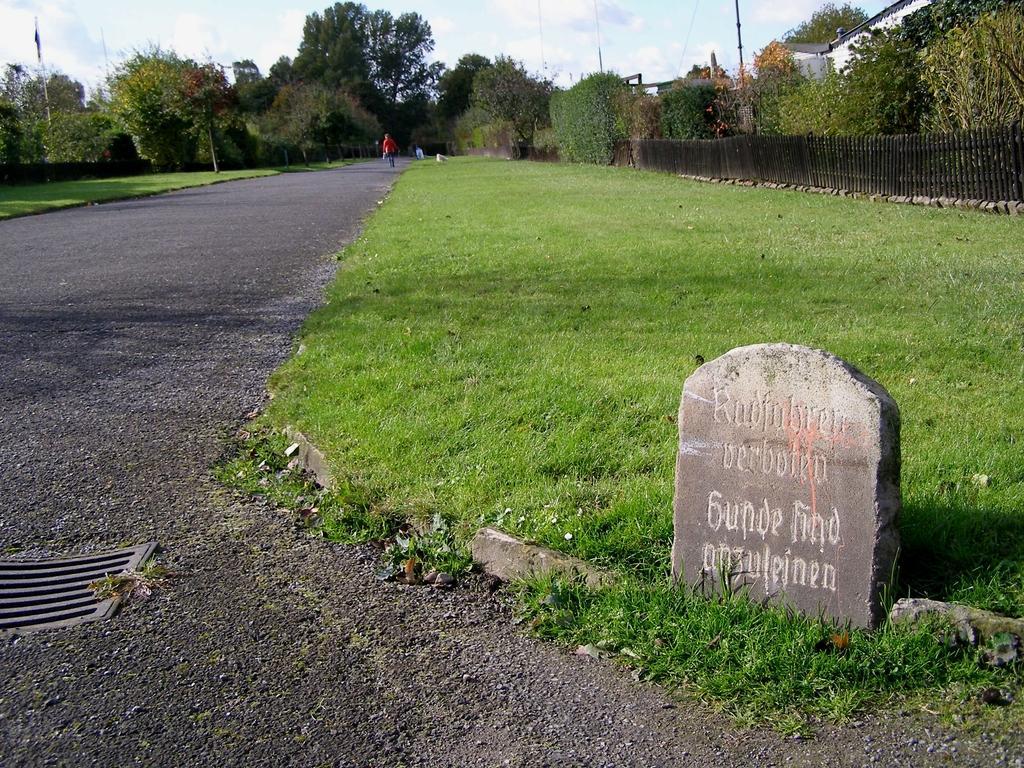Please provide a concise description of this image. In this picture I can see the road and the grass in front and I can see a stone in front, on which there is something written. In the background I can see the trees, a person's, few poles, wires, buildings and the railing. 